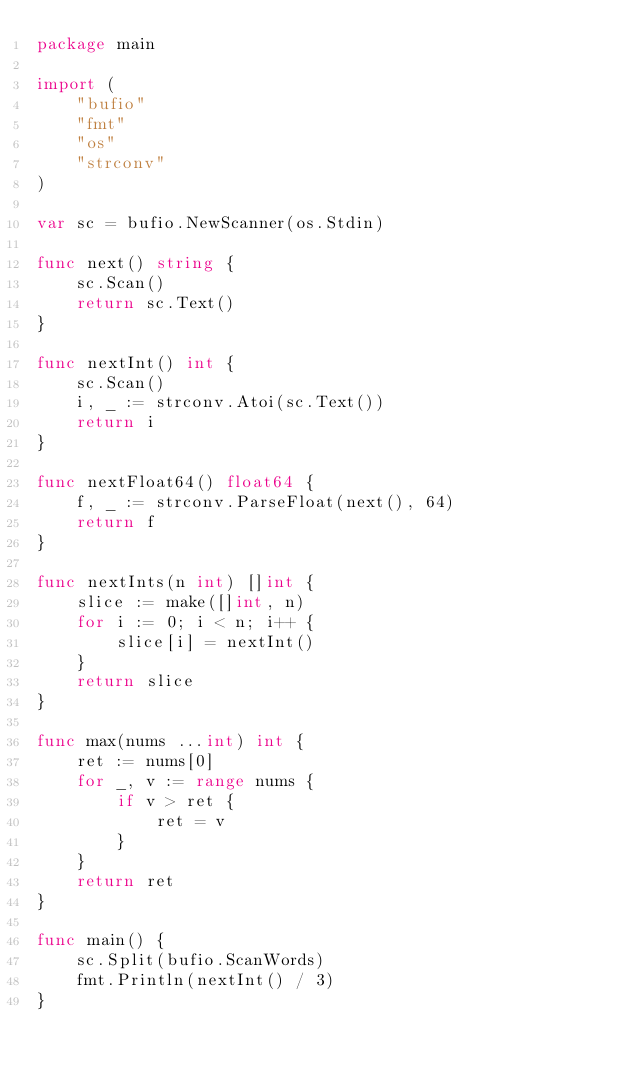<code> <loc_0><loc_0><loc_500><loc_500><_Go_>package main

import (
	"bufio"
	"fmt"
	"os"
	"strconv"
)

var sc = bufio.NewScanner(os.Stdin)

func next() string {
	sc.Scan()
	return sc.Text()
}

func nextInt() int {
	sc.Scan()
	i, _ := strconv.Atoi(sc.Text())
	return i
}

func nextFloat64() float64 {
	f, _ := strconv.ParseFloat(next(), 64)
	return f
}

func nextInts(n int) []int {
	slice := make([]int, n)
	for i := 0; i < n; i++ {
		slice[i] = nextInt()
	}
	return slice
}

func max(nums ...int) int {
	ret := nums[0]
	for _, v := range nums {
		if v > ret {
			ret = v
		}
	}
	return ret
}

func main() {
	sc.Split(bufio.ScanWords)
	fmt.Println(nextInt() / 3)
}
</code> 